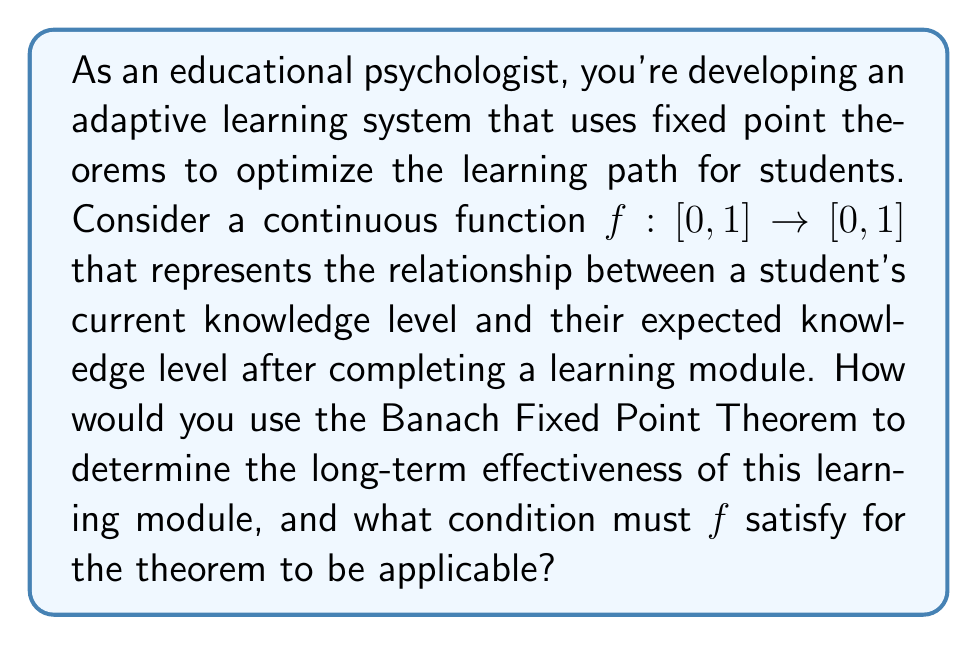Provide a solution to this math problem. To approach this problem, we need to understand the Banach Fixed Point Theorem and its applications in the context of learning optimization:

1. Banach Fixed Point Theorem: Let $(X,d)$ be a complete metric space and $f: X \rightarrow X$ be a contraction mapping. Then $f$ has a unique fixed point in $X$.

2. In our context:
   - $X = [0,1]$ represents the range of possible knowledge levels
   - $d$ is the standard metric on $[0,1]$
   - $f$ is our function representing the learning module's effect

3. For the Banach Fixed Point Theorem to be applicable, $f$ must be a contraction mapping. This means there exists a constant $k \in [0,1)$ such that:

   $$d(f(x), f(y)) \leq k \cdot d(x,y)$$ for all $x,y \in [0,1]$

4. If $f$ satisfies this condition, the theorem guarantees:
   a) There exists a unique fixed point $x^* \in [0,1]$ such that $f(x^*) = x^*$
   b) For any initial point $x_0 \in [0,1]$, the sequence $x_n = f(x_{n-1})$ converges to $x^*$

5. Interpretation in the learning context:
   - The fixed point $x^*$ represents the long-term knowledge level achieved through repeated use of the learning module
   - The contraction condition ensures that the learning module consistently brings students closer to this optimal level, regardless of their starting point

6. To determine long-term effectiveness:
   a) Verify that $f$ is a contraction mapping
   b) Find the fixed point $x^*$ by solving $f(x) = x$
   c) Analyze the value of $x^*$ to assess the module's effectiveness

7. The condition $f$ must satisfy is the contraction mapping property:
   $$|f(x) - f(y)| \leq k|x - y|$$ for some $k \in [0,1)$ and all $x,y \in [0,1]$

This condition ensures that the learning module consistently improves students' knowledge levels and converges to a stable long-term outcome.
Answer: The Banach Fixed Point Theorem can be used to determine the long-term effectiveness of the learning module by finding the unique fixed point $x^*$, which represents the ultimate knowledge level achieved. The function $f$ must satisfy the contraction mapping condition: $|f(x) - f(y)| \leq k|x - y|$ for some $k \in [0,1)$ and all $x,y \in [0,1]$. 